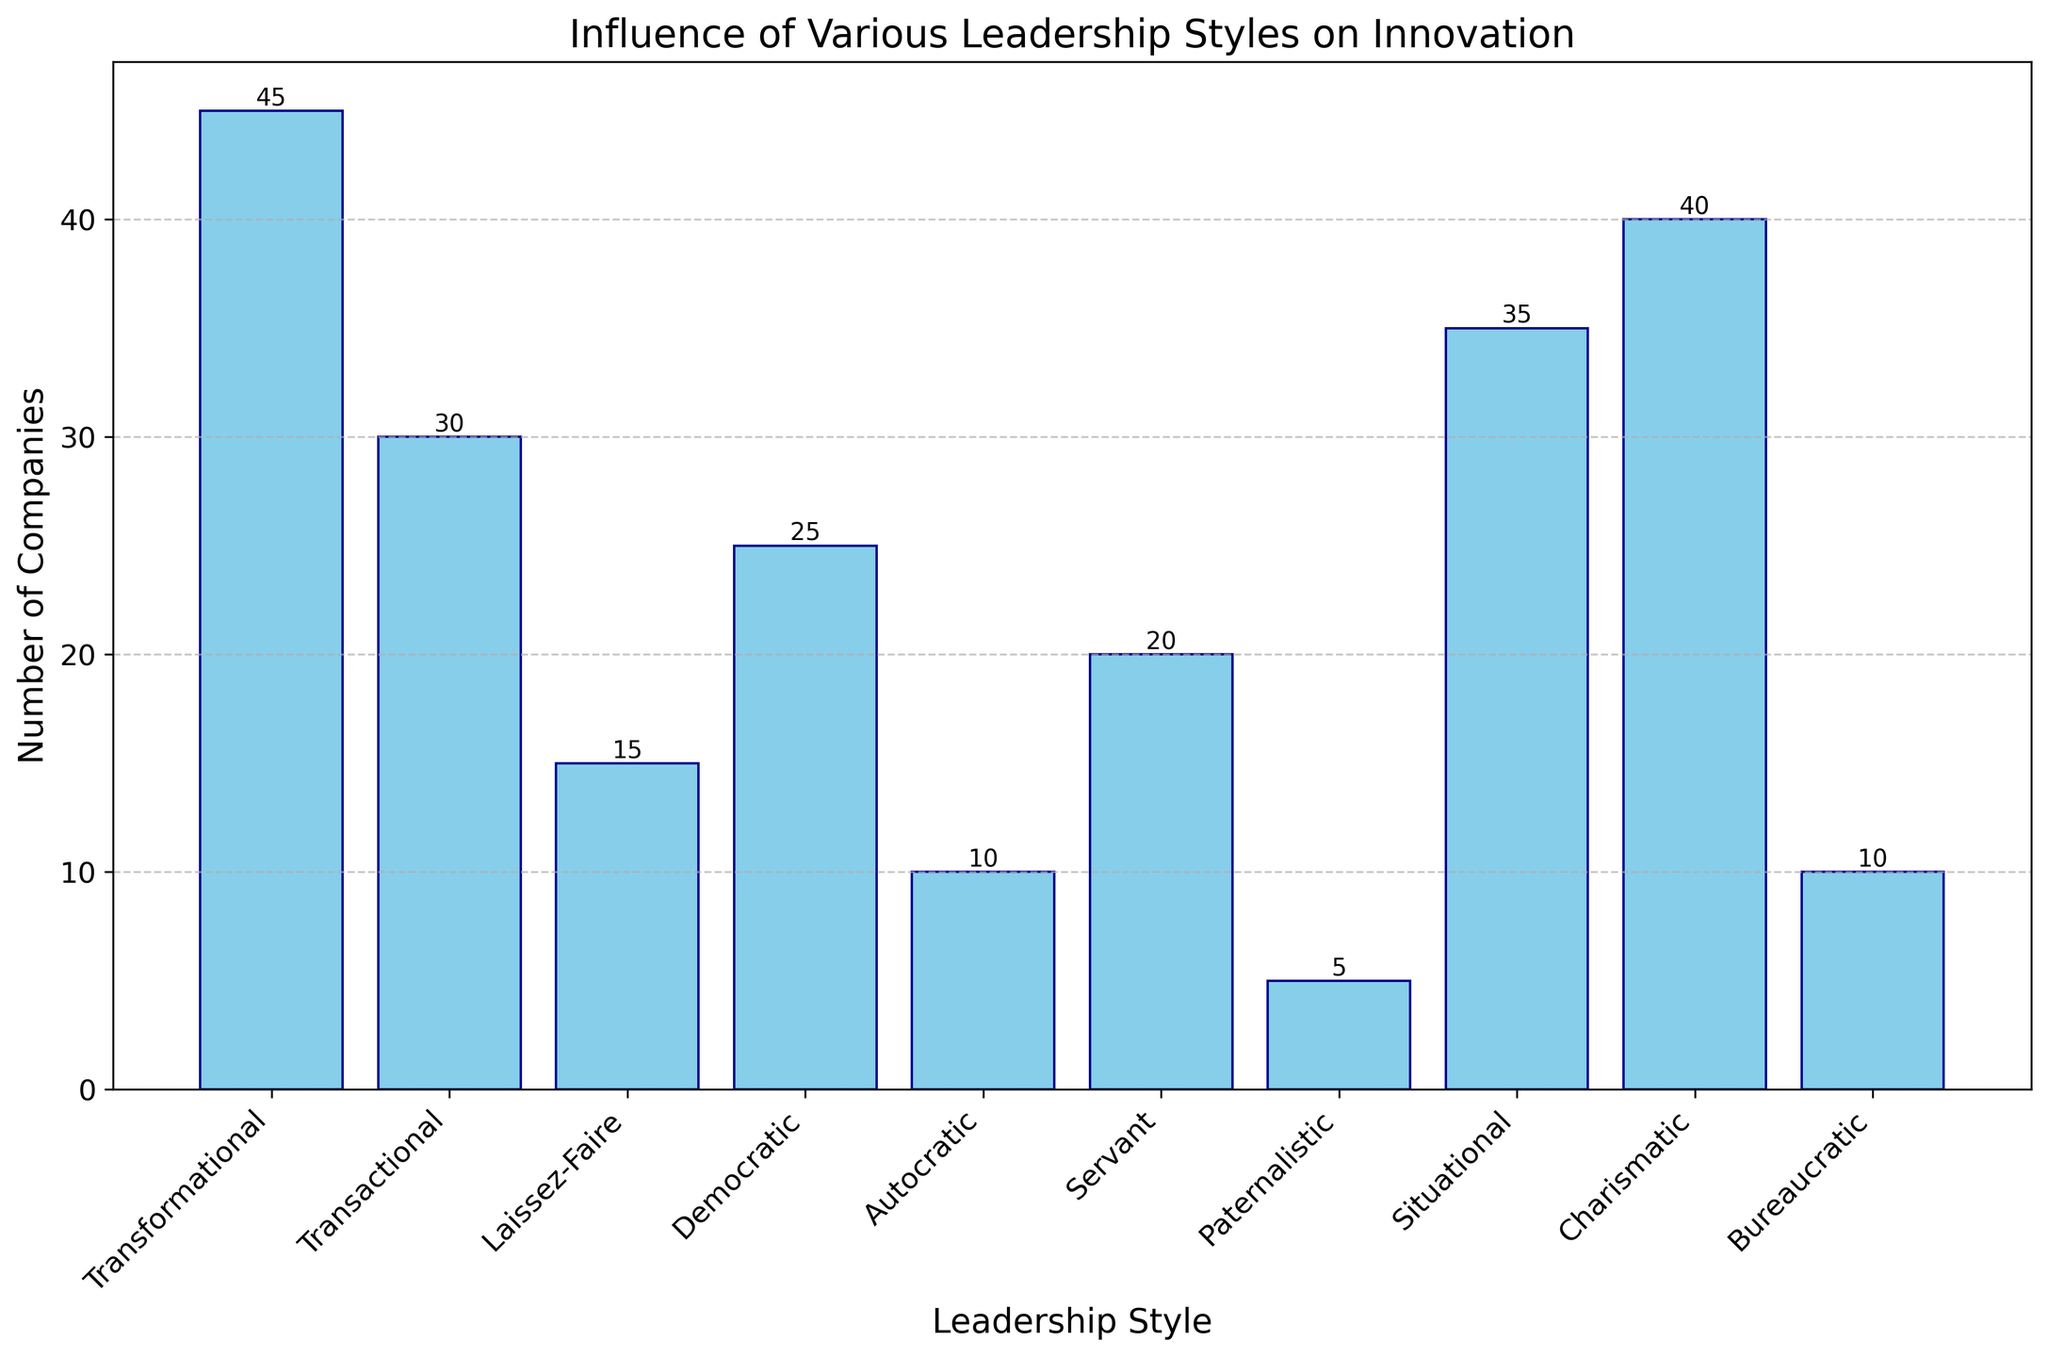Which leadership style has the highest number of companies associated with it? The tallest bar in the chart represents the leadership style with the highest number of companies. By observing the heights of the bars, we identify that 'Transformational' has the tallest bar.
Answer: Transformational How many more companies are there with transformational leadership style compared to democratic leadership style? The bar representing transformational leadership style shows 45 companies, and the bar for democratic leadership style shows 25 companies. Subtracting these values (45 - 25) gives the difference.
Answer: 20 What is the total number of companies with transformational, charismatic, and situational leadership styles combined? The bar for transformational leadership style shows 45 companies, charismatic shows 40, and situational shows 35. Adding these values (45 + 40 + 35) gives the total.
Answer: 120 Which leadership style has the least number of companies associated with it, and how many companies does it have? The shortest bar in the chart represents the leadership style with the fewest number of companies. By observing the smallest bar, we identify that 'Paternalistic' has 5 companies.
Answer: Paternalistic Compare the number of companies with laissez-faire and servant leadership styles. Which one has fewer companies, and what are their counts? The bar for laissez-faire leadership style shows 15 companies, and the bar for servant leadership style shows 20 companies. Laissez-faire has fewer companies than servant.
Answer: Laissez-Faire, 15 vs 20 What is the combined percentage of companies using democratic and autocratic leadership styles out of the total number of companies mentioned? The bar for democratic leadership style shows 25 companies, and for autocratic 10 companies. Adding them gives 35. The total number of companies is the sum of all bars: 45 + 30 + 15 + 25 + 10 + 20 + 5 + 35 + 40 + 10 = 235. The percentage is (35 / 235) * 100.
Answer: 14.89% On average, how many companies are represented per leadership style? The total number of companies is 235, and there are 10 leadership styles. The average is calculated by dividing the total number of companies by the number of leadership styles (235 / 10).
Answer: 23.5 Which two leadership styles combined have a total number of companies closest to 50? Looking at the bars, we need to find two leadership styles that, when combined, have a total near 50. Transformational (45) and Paternalistic (5) add up closest (45 + 5 = 50).
Answer: Transformational and Paternalistic Is the number of companies with transformational leadership style greater than the combined total of laissez-faire and autocratic styles? The number of companies with transformational leadership style is 45. The sum of laissez-faire (15) and autocratic (10) is 25. Since 45 is greater than 25, the comparison holds.
Answer: Yes 